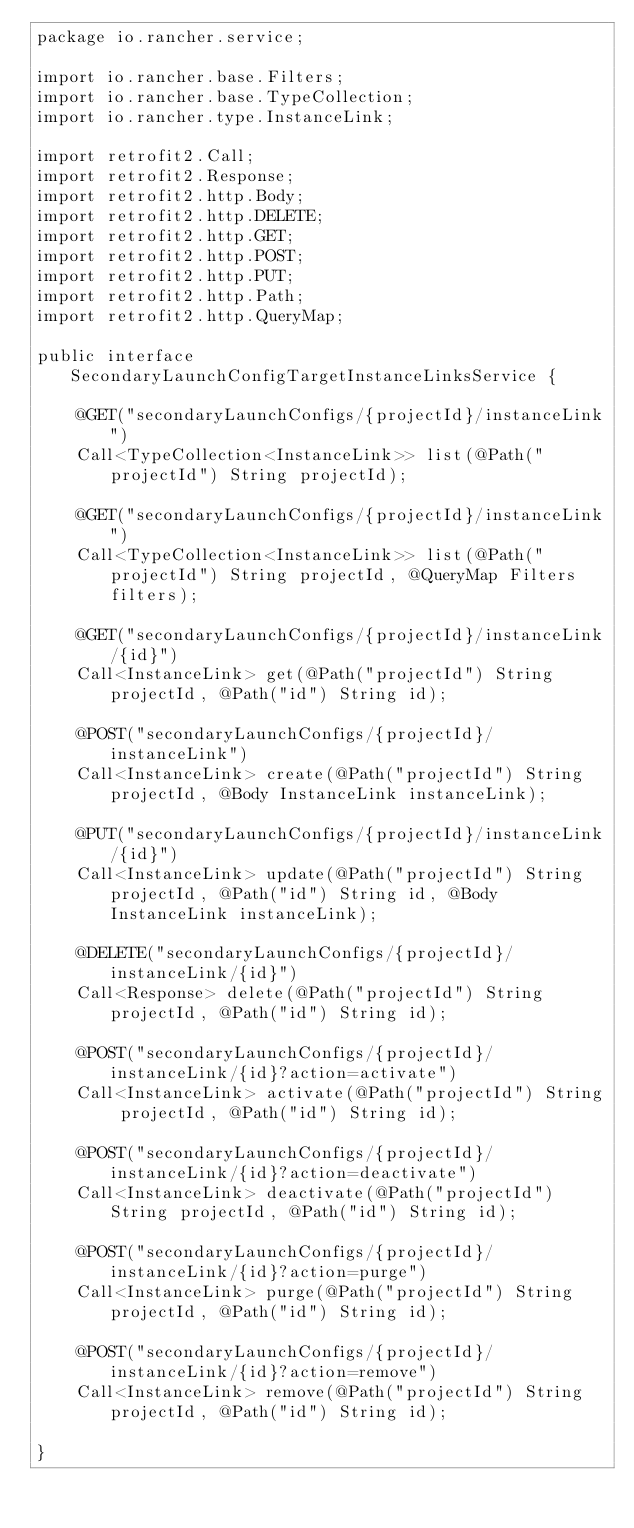Convert code to text. <code><loc_0><loc_0><loc_500><loc_500><_Java_>package io.rancher.service;

import io.rancher.base.Filters;
import io.rancher.base.TypeCollection;
import io.rancher.type.InstanceLink;

import retrofit2.Call;
import retrofit2.Response;
import retrofit2.http.Body;
import retrofit2.http.DELETE;
import retrofit2.http.GET;
import retrofit2.http.POST;
import retrofit2.http.PUT;
import retrofit2.http.Path;
import retrofit2.http.QueryMap;

public interface SecondaryLaunchConfigTargetInstanceLinksService {

    @GET("secondaryLaunchConfigs/{projectId}/instanceLink")
    Call<TypeCollection<InstanceLink>> list(@Path("projectId") String projectId);

    @GET("secondaryLaunchConfigs/{projectId}/instanceLink")
    Call<TypeCollection<InstanceLink>> list(@Path("projectId") String projectId, @QueryMap Filters filters);

    @GET("secondaryLaunchConfigs/{projectId}/instanceLink/{id}")
    Call<InstanceLink> get(@Path("projectId") String projectId, @Path("id") String id);

    @POST("secondaryLaunchConfigs/{projectId}/instanceLink")
    Call<InstanceLink> create(@Path("projectId") String projectId, @Body InstanceLink instanceLink);

    @PUT("secondaryLaunchConfigs/{projectId}/instanceLink/{id}")
    Call<InstanceLink> update(@Path("projectId") String projectId, @Path("id") String id, @Body InstanceLink instanceLink);

    @DELETE("secondaryLaunchConfigs/{projectId}/instanceLink/{id}")
    Call<Response> delete(@Path("projectId") String projectId, @Path("id") String id);
    
    @POST("secondaryLaunchConfigs/{projectId}/instanceLink/{id}?action=activate")
    Call<InstanceLink> activate(@Path("projectId") String projectId, @Path("id") String id);
    
    @POST("secondaryLaunchConfigs/{projectId}/instanceLink/{id}?action=deactivate")
    Call<InstanceLink> deactivate(@Path("projectId") String projectId, @Path("id") String id);
    
    @POST("secondaryLaunchConfigs/{projectId}/instanceLink/{id}?action=purge")
    Call<InstanceLink> purge(@Path("projectId") String projectId, @Path("id") String id);
    
    @POST("secondaryLaunchConfigs/{projectId}/instanceLink/{id}?action=remove")
    Call<InstanceLink> remove(@Path("projectId") String projectId, @Path("id") String id);
    
}
</code> 